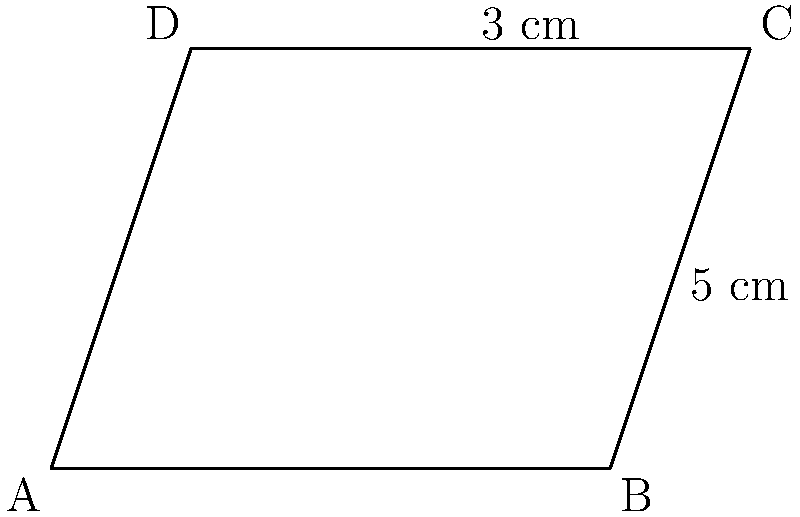In the parallelogram ABCD shown above, the base AB is 5 cm and the height AD is 3 cm. Calculate the area of the parallelogram. How would you use this result to evaluate the effectiveness of an online geometry course? To calculate the area of a parallelogram and evaluate the effectiveness of an online geometry course, let's follow these steps:

1) The formula for the area of a parallelogram is:
   $$\text{Area} = \text{base} \times \text{height}$$

2) We are given:
   Base (AB) = 5 cm
   Height (AD) = 3 cm

3) Substituting these values into the formula:
   $$\text{Area} = 5 \text{ cm} \times 3 \text{ cm} = 15 \text{ cm}^2$$

4) Therefore, the area of the parallelogram ABCD is 15 square centimeters.

5) To evaluate the effectiveness of an online geometry course:
   a) Check if you could easily recall the formula for the area of a parallelogram.
   b) Assess how quickly you could identify the base and height in the diagram.
   c) Evaluate your confidence in performing the calculation.
   d) Reflect on whether you understand why this formula works for all parallelograms.
   e) Consider if you could apply this knowledge to real-world problems.

6) Provide feedback on:
   a) Clarity of the course materials in explaining parallelogram properties.
   b) Effectiveness of visual aids in illustrating concepts.
   c) Quality of practice problems provided.
   d) Suggestions for improving the course based on any difficulties encountered.

This approach combines applying geometric knowledge with critical thinking about the learning process, aligning with the persona of a motivated learner who provides valuable feedback.
Answer: $15 \text{ cm}^2$ 